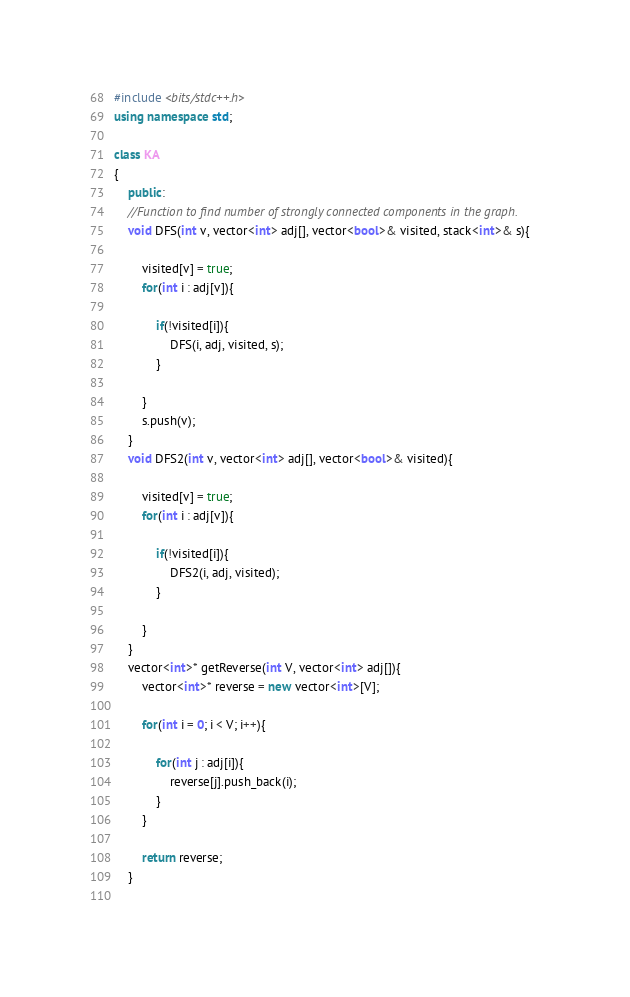<code> <loc_0><loc_0><loc_500><loc_500><_C++_>#include <bits/stdc++.h>
using namespace std;

class KA
{
	public:
	//Function to find number of strongly connected components in the graph.
	void DFS(int v, vector<int> adj[], vector<bool>& visited, stack<int>& s){
	    
	    visited[v] = true;
	    for(int i : adj[v]){
	        
	        if(!visited[i]){
	            DFS(i, adj, visited, s);
	        }
	        
	    }
	    s.push(v);
	}
	void DFS2(int v, vector<int> adj[], vector<bool>& visited){
	    
	    visited[v] = true;
	    for(int i : adj[v]){
	        
	        if(!visited[i]){
	            DFS2(i, adj, visited);
	        }
	        
	    }
	}
	vector<int>* getReverse(int V, vector<int> adj[]){
	    vector<int>* reverse = new vector<int>[V];
	    
	    for(int i = 0; i < V; i++){
	        
	        for(int j : adj[i]){
	            reverse[j].push_back(i);
	        }
	    }
	    
	    return reverse;
	}
	</code> 